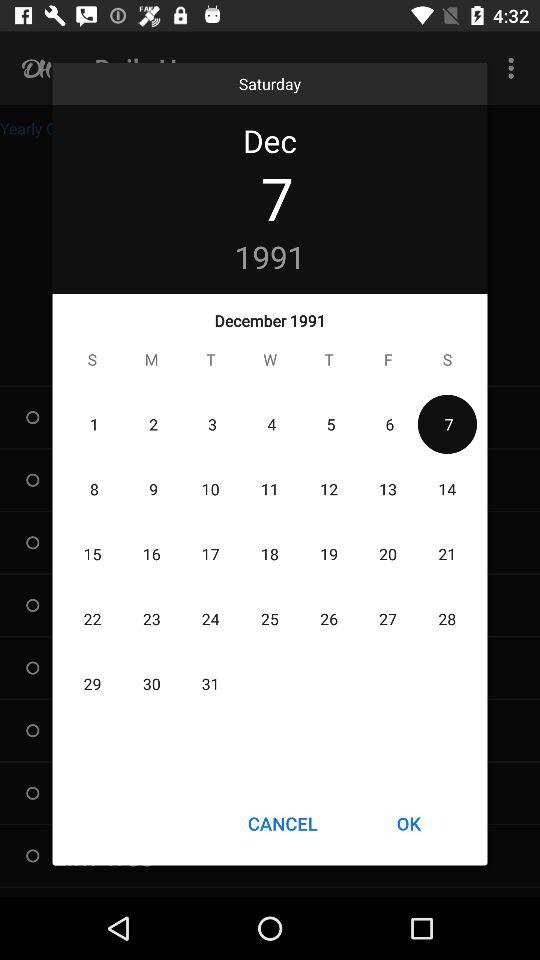Which holiday falls on December 7, 1991?
When the provided information is insufficient, respond with <no answer>. <no answer> 